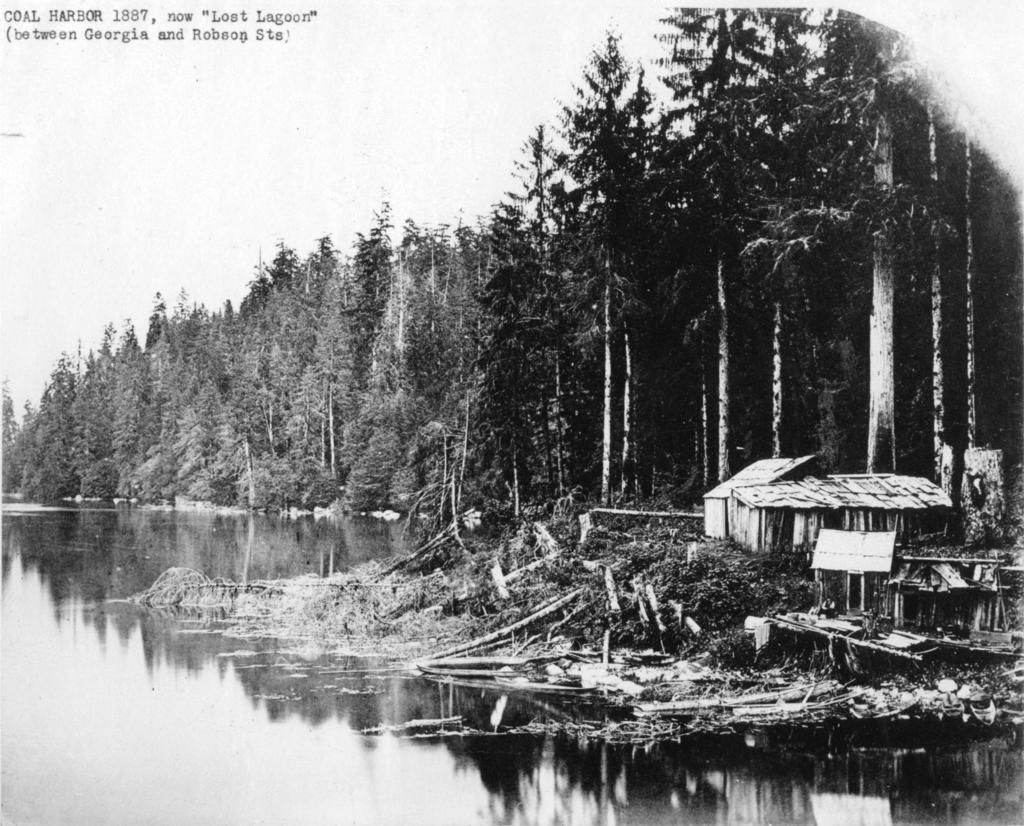What is the primary element visible in the image? There is water in the image. What structure can be seen on the right side of the image? There is a hut on the right side of the image. What else is present on the right side of the image besides the hut? There are other objects on the right side of the image. What can be seen in the background of the image? There are trees and the sky visible in the background of the image. Can you tell me how many curtains are hanging in the trees in the image? There are no curtains present in the image; it features water, a hut, other objects, trees, and the sky. Are there any dinosaurs visible in the image? There are no dinosaurs present in the image. 